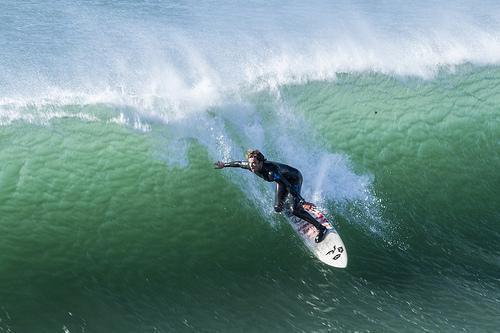How many surfers are wearing orange wetsuits?
Give a very brief answer. 0. 